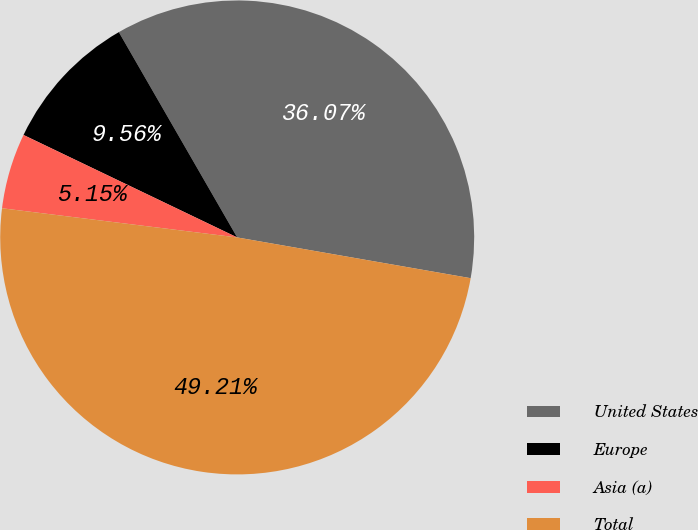Convert chart. <chart><loc_0><loc_0><loc_500><loc_500><pie_chart><fcel>United States<fcel>Europe<fcel>Asia (a)<fcel>Total<nl><fcel>36.07%<fcel>9.56%<fcel>5.15%<fcel>49.21%<nl></chart> 